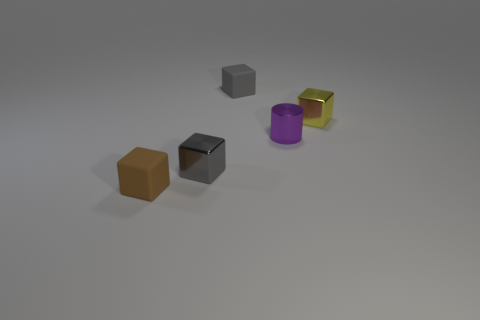Add 1 big yellow metal objects. How many objects exist? 6 Subtract all cubes. How many objects are left? 1 Subtract all tiny gray rubber balls. Subtract all purple cylinders. How many objects are left? 4 Add 1 small purple metal cylinders. How many small purple metal cylinders are left? 2 Add 4 large red matte things. How many large red matte things exist? 4 Subtract 0 green balls. How many objects are left? 5 